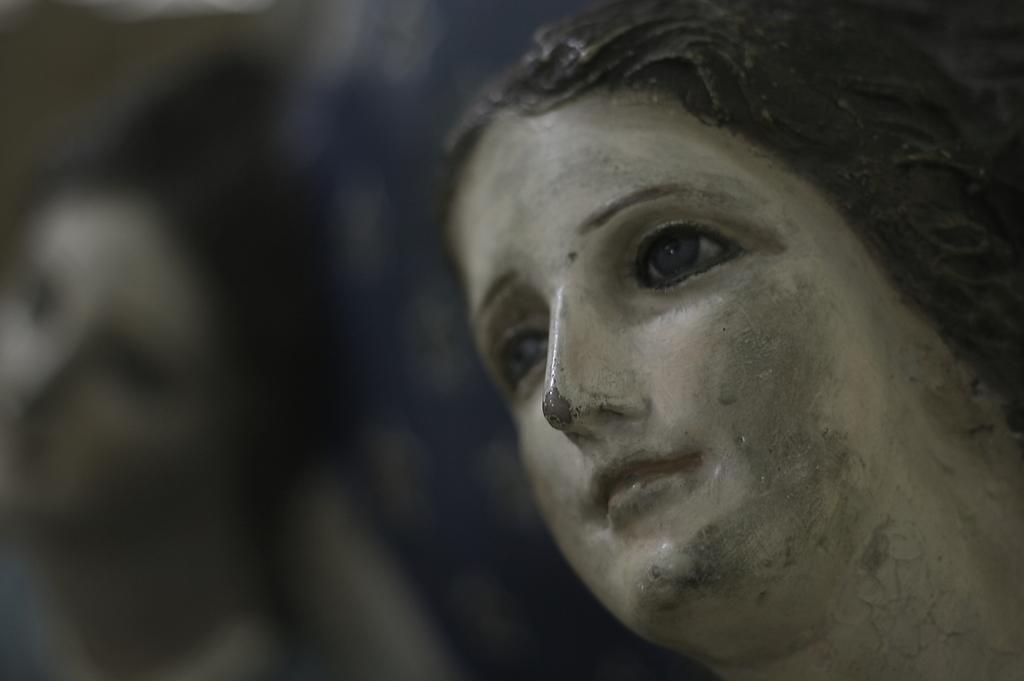What is depicted in the image? There are statues of women in the image. Can you describe the background of the image? The background of the image is blurry. What type of coat is the statue wearing in the image? The statues in the image are not wearing coats, as they are made of a material that does not require clothing. 